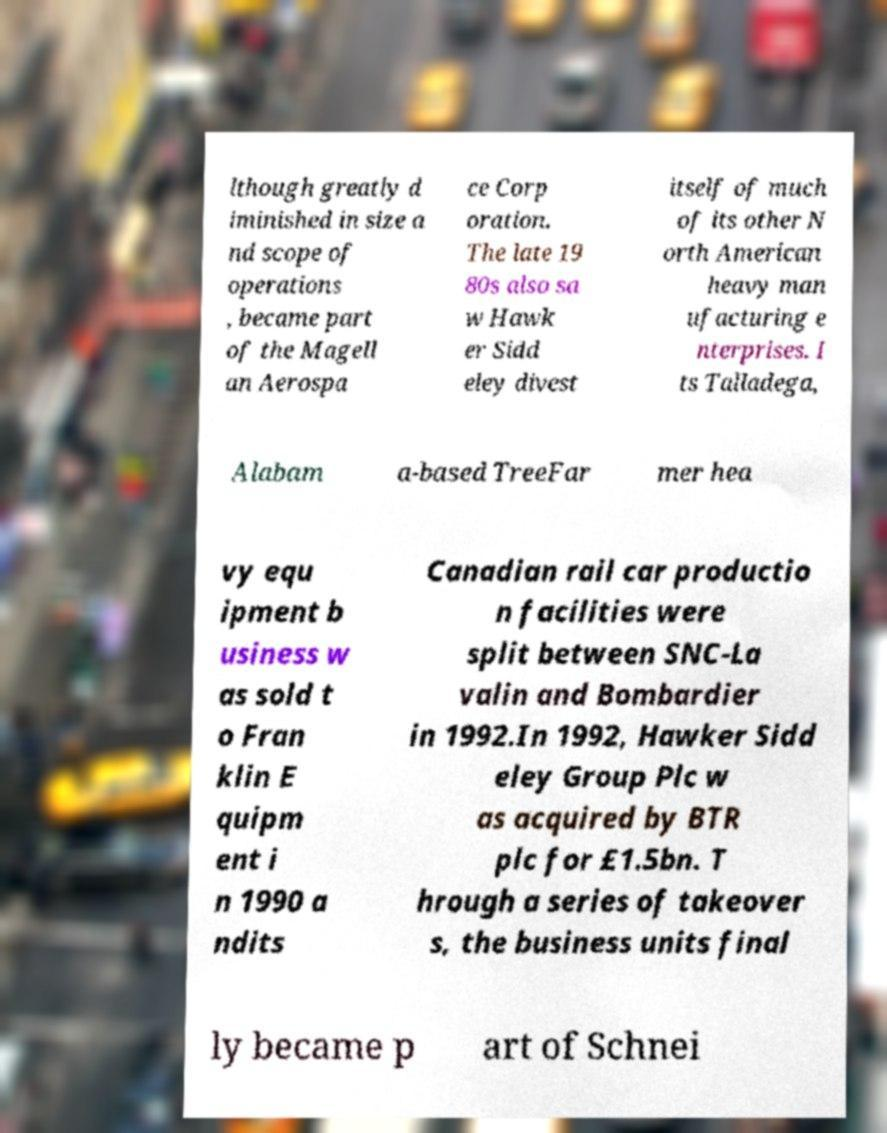For documentation purposes, I need the text within this image transcribed. Could you provide that? lthough greatly d iminished in size a nd scope of operations , became part of the Magell an Aerospa ce Corp oration. The late 19 80s also sa w Hawk er Sidd eley divest itself of much of its other N orth American heavy man ufacturing e nterprises. I ts Talladega, Alabam a-based TreeFar mer hea vy equ ipment b usiness w as sold t o Fran klin E quipm ent i n 1990 a ndits Canadian rail car productio n facilities were split between SNC-La valin and Bombardier in 1992.In 1992, Hawker Sidd eley Group Plc w as acquired by BTR plc for £1.5bn. T hrough a series of takeover s, the business units final ly became p art of Schnei 